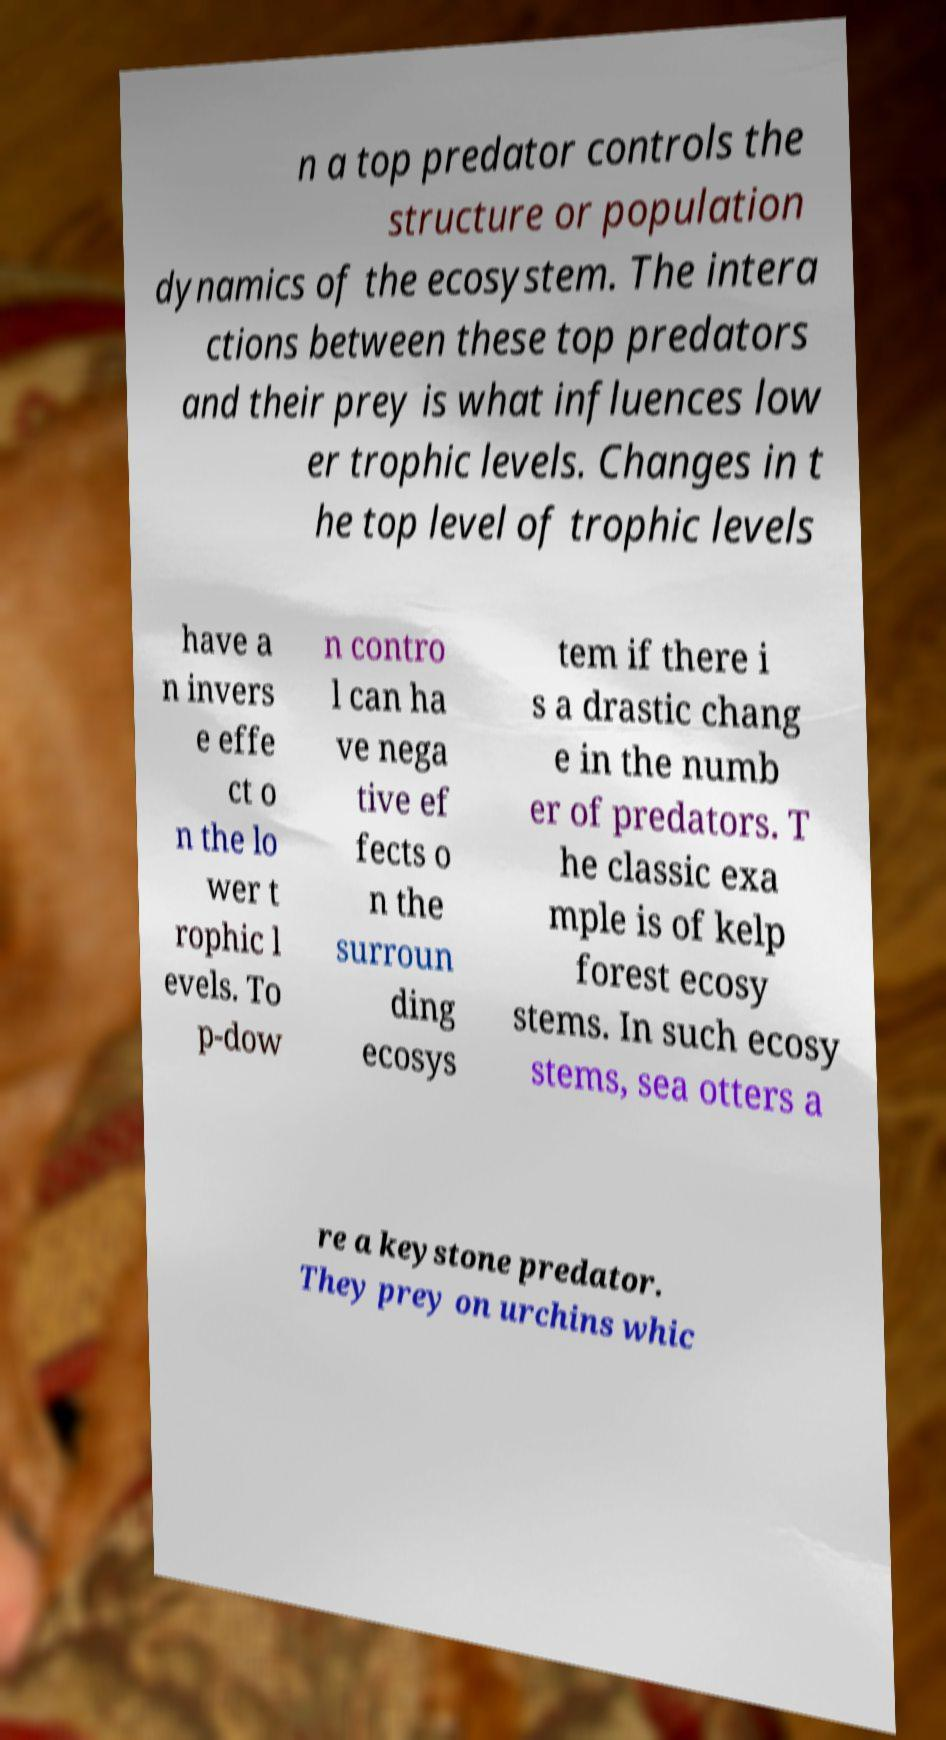What messages or text are displayed in this image? I need them in a readable, typed format. n a top predator controls the structure or population dynamics of the ecosystem. The intera ctions between these top predators and their prey is what influences low er trophic levels. Changes in t he top level of trophic levels have a n invers e effe ct o n the lo wer t rophic l evels. To p-dow n contro l can ha ve nega tive ef fects o n the surroun ding ecosys tem if there i s a drastic chang e in the numb er of predators. T he classic exa mple is of kelp forest ecosy stems. In such ecosy stems, sea otters a re a keystone predator. They prey on urchins whic 